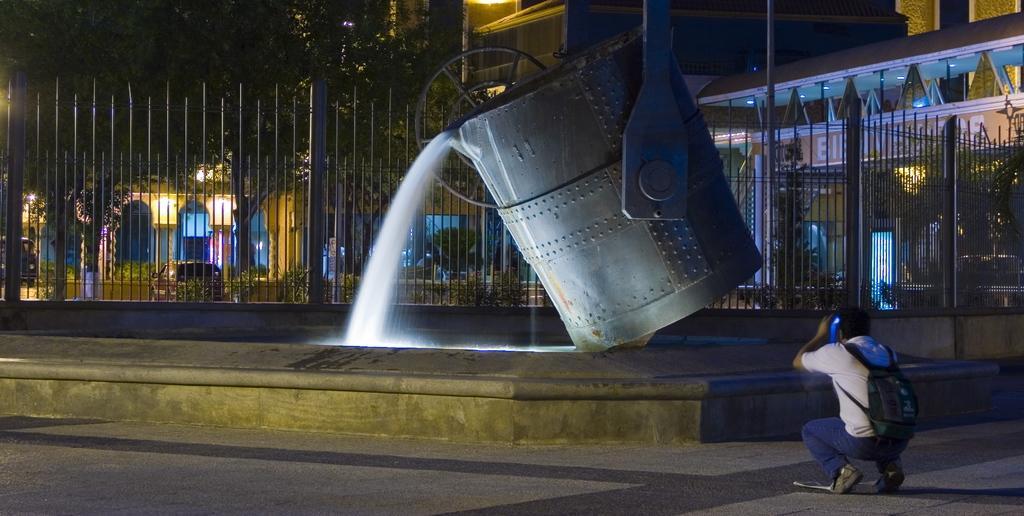Describe this image in one or two sentences. In this picture at front there is a fountain and person is capturing the picture. At the back side there are trees, buildings. 